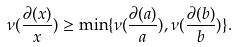Convert formula to latex. <formula><loc_0><loc_0><loc_500><loc_500>\nu ( \frac { \partial ( x ) } x ) \geq \min \{ \nu ( \frac { \partial ( a ) } a ) , \nu ( \frac { \partial ( b ) } b ) \} .</formula> 